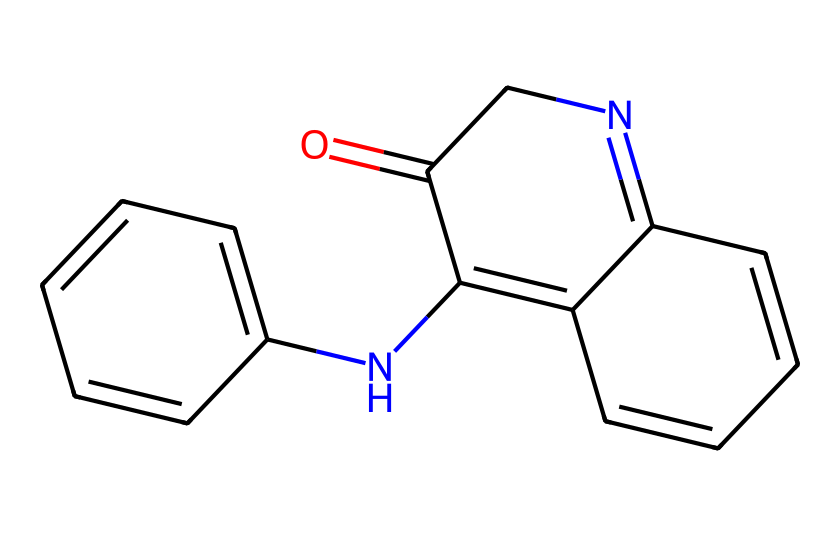What is the molecular formula for this dye? To determine the molecular formula, we need to count the number of carbon (C), hydrogen (H), nitrogen (N), and oxygen (O) atoms in the SMILES representation. The structure indicates 16 carbons, 15 hydrogens, 2 nitrogens, and 1 oxygen. Therefore, the molecular formula is C16H15N2O.
Answer: C16H15N2O How many rings are present in the molecule? The structure of this chemical reveals two distinct fused ring systems. Each ring is counted separately, giving us three rings in total.
Answer: three What functional groups can be identified in the structure? A careful analysis of the chemical structure shows one carbonyl group (C=O) and two nitrogen atoms within the aromatic rings, indicating the presence of amine and possibly imine functionalities as well. Thus, the identified functional groups are carbonyl and amine.
Answer: carbonyl and amine What type of bonding primarily affects the color properties of this dye? The presence of conjugated double bonds in the extended π system allows for delocalization of electrons, which primarily affects the color properties of this dye through resonance. Thus, conjugation is key to its color characteristics.
Answer: conjugation Is this dye considered a natural or synthetic dye? This specific structure corresponds to a natural dye, as indigo is traditionally derived from natural sources like the indigo plant. Hence, it is classified as a natural dye.
Answer: natural What is the primary application of this dye in textiles? The main application of this dye is for imparting blue color to textiles, specifically in dyeing denim and other fabrics. Therefore, its primary usage in textiles is for coloring purposes.
Answer: blue color 